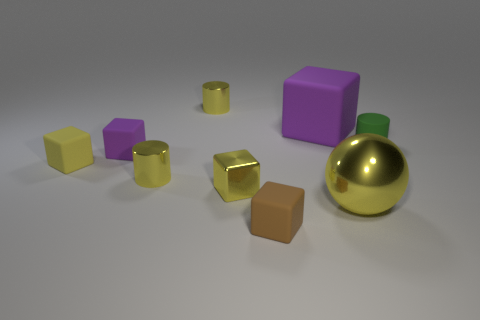What shape is the big rubber thing?
Your answer should be compact. Cube. Does the large yellow sphere have the same material as the cylinder that is right of the big yellow metal thing?
Your answer should be compact. No. What number of tiny purple blocks are to the left of the yellow matte block that is to the left of the cylinder in front of the yellow rubber cube?
Offer a very short reply. 0. Is the number of big things on the left side of the brown rubber block less than the number of tiny shiny blocks that are behind the small purple block?
Your answer should be compact. No. How many other objects are there of the same material as the small green cylinder?
Provide a succinct answer. 4. What is the material of the purple cube that is the same size as the sphere?
Keep it short and to the point. Rubber. What number of yellow objects are small metal blocks or tiny rubber cylinders?
Make the answer very short. 1. The object that is behind the big yellow metal thing and right of the big cube is what color?
Offer a terse response. Green. Does the cylinder that is on the right side of the tiny brown object have the same material as the tiny cylinder behind the small green matte thing?
Your answer should be compact. No. Is the number of small yellow shiny things that are in front of the tiny yellow matte block greater than the number of small purple objects that are on the right side of the brown thing?
Offer a very short reply. Yes. 